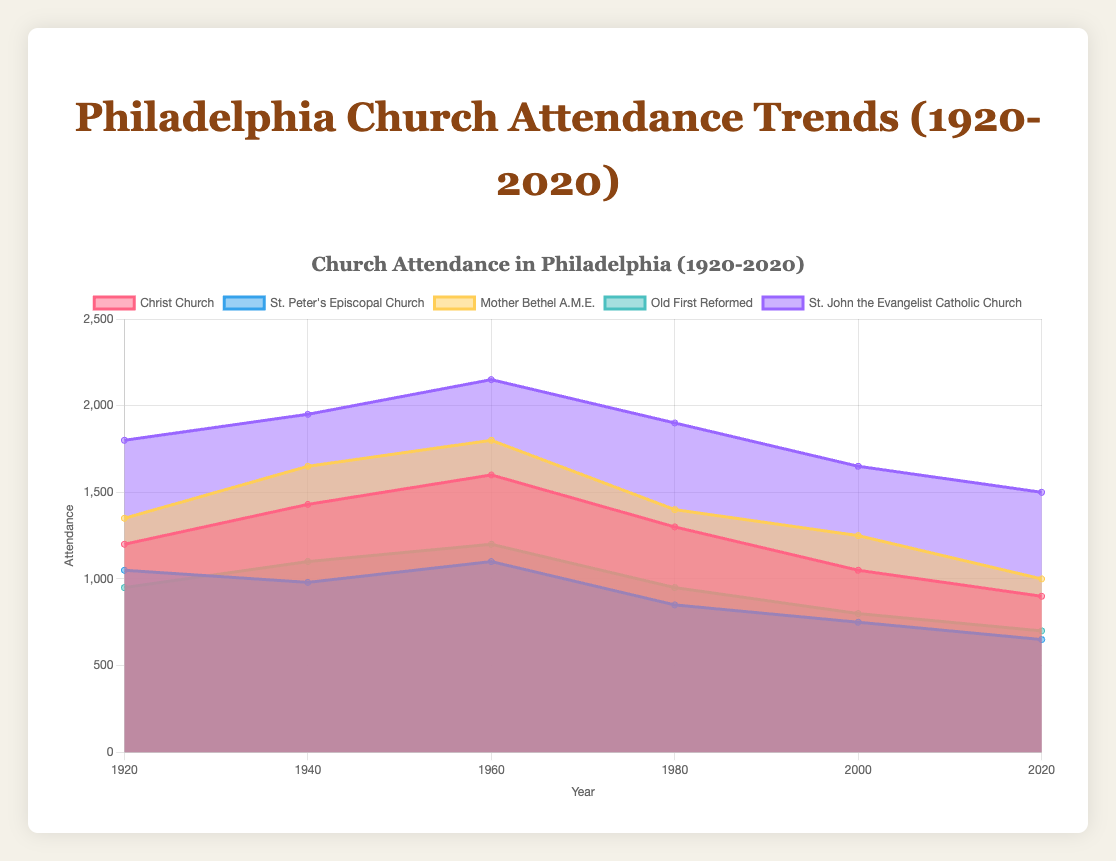What is the overall trend in the attendance of Christ Church from 1920 to 2020? To determine the trend, we observe the data points for Christ Church over the years: 1200 (1920), 1430 (1940), 1600 (1960), 1300 (1980), 1050 (2000), and 900 (2020). There is a general increase from 1920 to 1960, followed by a steady decline from 1960 to 2020.
Answer: Increasing till 1960, then decreasing What year recorded the highest attendance for Mother Bethel A.M.E.? Examine the data points for Mother Bethel A.M.E.'s attendance over the years to find the maximum value: 1350 (1920), 1650 (1940), 1800 (1960), 1400 (1980), 1250 (2000), and 1000 (2020). The peak is 1800 in 1960.
Answer: 1960 How many years of data are represented for Old First Reformed? Count the number of distinct years shown on the x-axis of the chart or listed in the data: 1920, 1940, 1960, 1980, 2000, and 2020. There are 6 years represented.
Answer: 6 years What was the attendance range (difference between max and min) for St. John the Evangelist Catholic Church over the century? Identify the maximum and minimum values for St. John the Evangelist Catholic Church: Max is 2150 (1960), and Min is 1500 (2020). Calculate the range: 2150 - 1500 = 650.
Answer: 650 